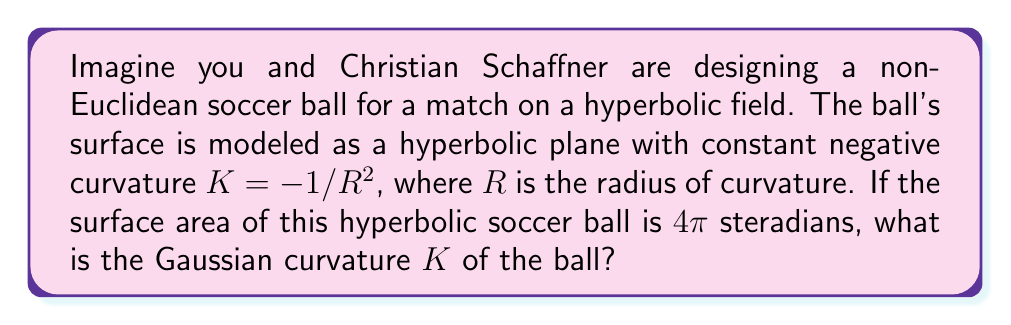Teach me how to tackle this problem. Let's approach this step-by-step:

1) In hyperbolic geometry, the surface area $A$ of a sphere with radius of curvature $R$ is given by:

   $$A = 4\pi\sinh^2\left(\frac{r}{R}\right)$$

   where $r$ is the radius of the sphere in the embedding space.

2) We're given that the surface area is 4π steradians. So:

   $$4\pi = 4\pi\sinh^2\left(\frac{r}{R}\right)$$

3) Simplifying:

   $$1 = \sinh^2\left(\frac{r}{R}\right)$$

4) Taking the inverse hyperbolic sine (arcsinh) of both sides:

   $$\frac{r}{R} = \arcsinh(1)$$

5) The value of $\arcsinh(1)$ is approximately 0.8814.

6) Now, recall that the Gaussian curvature $K$ is related to the radius of curvature $R$ by:

   $$K = -\frac{1}{R^2}$$

7) We don't need to find $R$ explicitly. We can use the fact that $r/R = 0.8814$ to say:

   $$K = -\frac{1}{R^2} = -\left(\frac{r}{R}\right)^2 \cdot \frac{1}{r^2} = -(0.8814)^2 \cdot \frac{1}{r^2}$$

8) Therefore, the Gaussian curvature is:

   $$K = -\frac{0.7769}{r^2}$$

   where $r$ is the radius of the hyperbolic soccer ball in the embedding space.
Answer: $K = -\frac{0.7769}{r^2}$ 